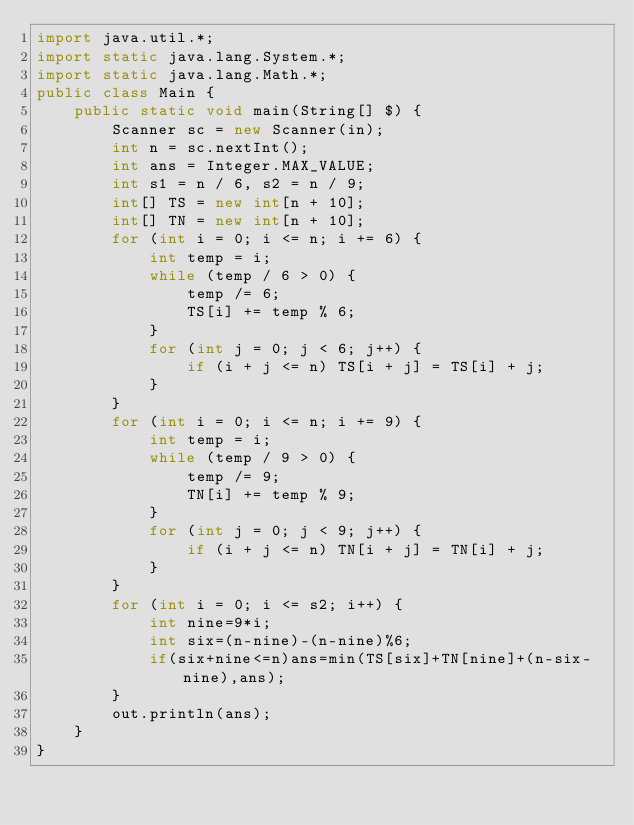Convert code to text. <code><loc_0><loc_0><loc_500><loc_500><_Java_>import java.util.*;
import static java.lang.System.*;
import static java.lang.Math.*;
public class Main {
    public static void main(String[] $) {
        Scanner sc = new Scanner(in);
        int n = sc.nextInt();
        int ans = Integer.MAX_VALUE;
        int s1 = n / 6, s2 = n / 9;
        int[] TS = new int[n + 10];
        int[] TN = new int[n + 10];
        for (int i = 0; i <= n; i += 6) {
            int temp = i;
            while (temp / 6 > 0) {
                temp /= 6;
                TS[i] += temp % 6;
            }
            for (int j = 0; j < 6; j++) {
                if (i + j <= n) TS[i + j] = TS[i] + j;
            }
        }
        for (int i = 0; i <= n; i += 9) {
            int temp = i;
            while (temp / 9 > 0) {
                temp /= 9;
                TN[i] += temp % 9;
            }
            for (int j = 0; j < 9; j++) {
                if (i + j <= n) TN[i + j] = TN[i] + j;
            }
        }
        for (int i = 0; i <= s2; i++) {
            int nine=9*i;
            int six=(n-nine)-(n-nine)%6;
            if(six+nine<=n)ans=min(TS[six]+TN[nine]+(n-six-nine),ans);
        }
        out.println(ans);
    }
}</code> 